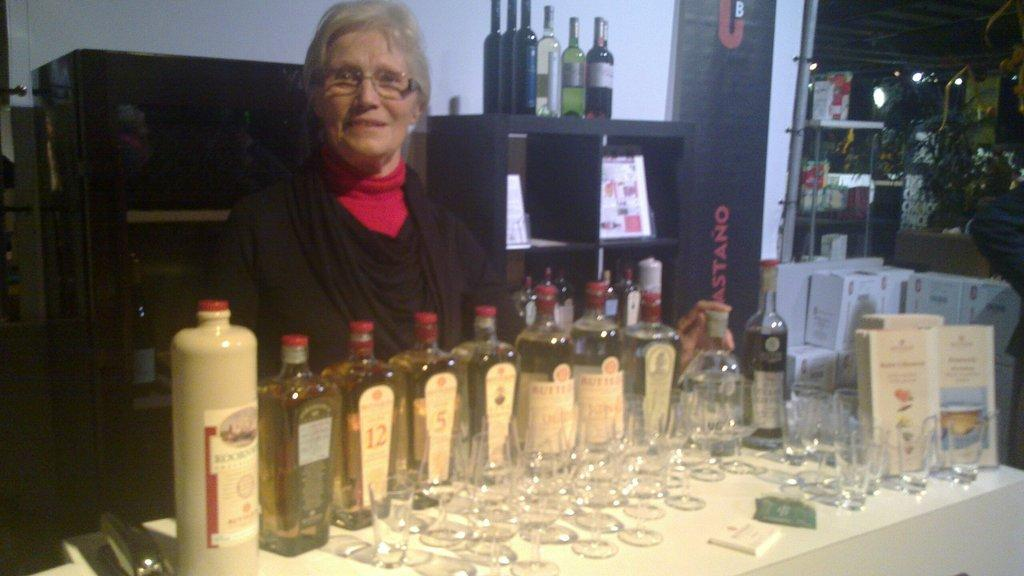Who is present in the image? There is a woman in the image. Where is the woman located in the image? The woman is standing on the right side. What objects can be seen on the table in the image? There are wine bottles and glasses on the table. What type of road can be seen in the image? There is no road present in the image. What kind of shoes is the woman wearing in the image? The image does not show the woman's shoes, so it cannot be determined from the image. 